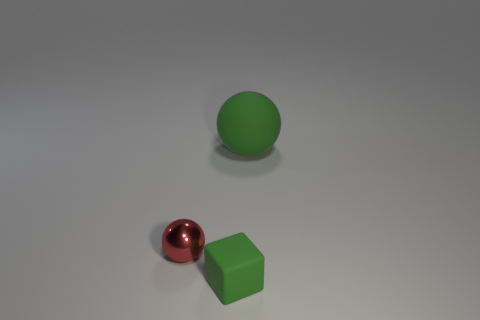Subtract 1 spheres. How many spheres are left? 1 Add 1 rubber spheres. How many objects exist? 4 Subtract all balls. How many objects are left? 1 Add 1 large yellow shiny cylinders. How many large yellow shiny cylinders exist? 1 Subtract 0 blue blocks. How many objects are left? 3 Subtract all green spheres. Subtract all brown cylinders. How many spheres are left? 1 Subtract all blue blocks. How many red spheres are left? 1 Subtract all big green rubber balls. Subtract all small matte things. How many objects are left? 1 Add 2 green blocks. How many green blocks are left? 3 